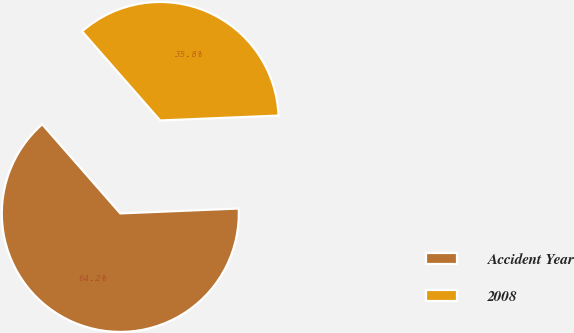Convert chart to OTSL. <chart><loc_0><loc_0><loc_500><loc_500><pie_chart><fcel>Accident Year<fcel>2008<nl><fcel>64.21%<fcel>35.79%<nl></chart> 